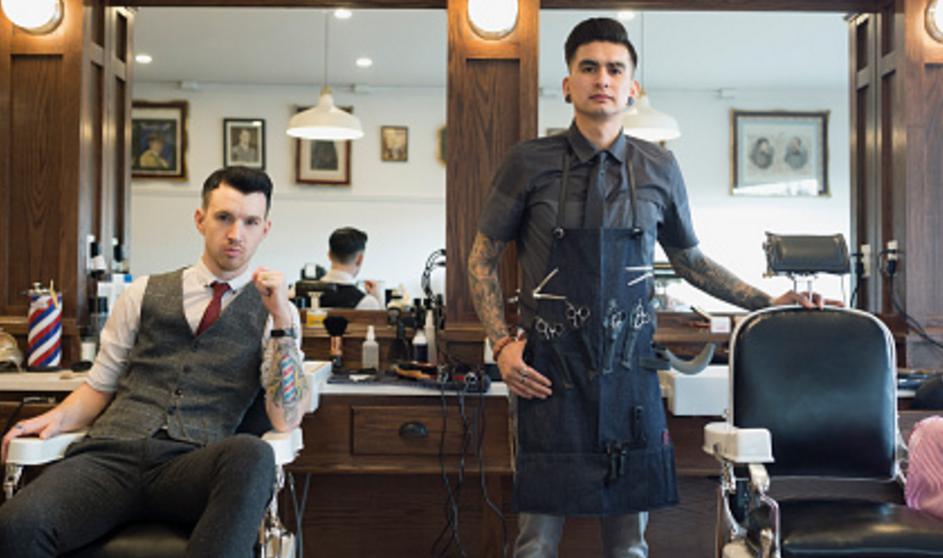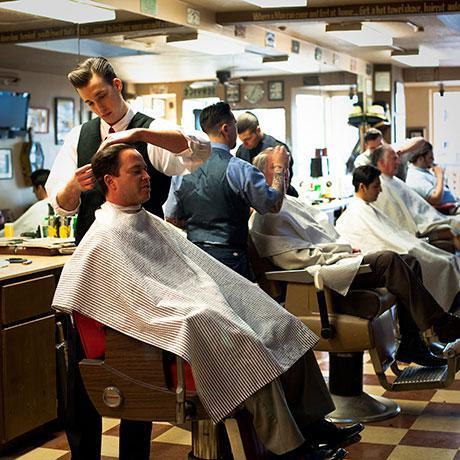The first image is the image on the left, the second image is the image on the right. Evaluate the accuracy of this statement regarding the images: "A camera-facing man is standing by a camera-facing empty black barber chair with white arms, in one image.". Is it true? Answer yes or no. Yes. The first image is the image on the left, the second image is the image on the right. Evaluate the accuracy of this statement regarding the images: "In one image a single barber is working with a customer, while a person stands at a store counter in the second image.". Is it true? Answer yes or no. No. 